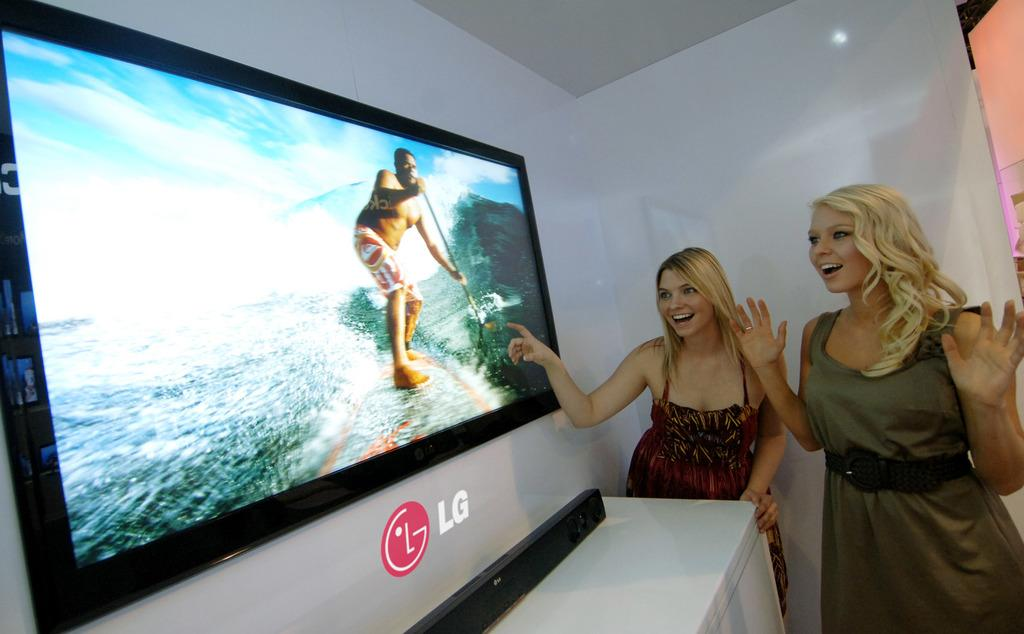<image>
Share a concise interpretation of the image provided. Women in front of a large tv with an LG logo under it. 